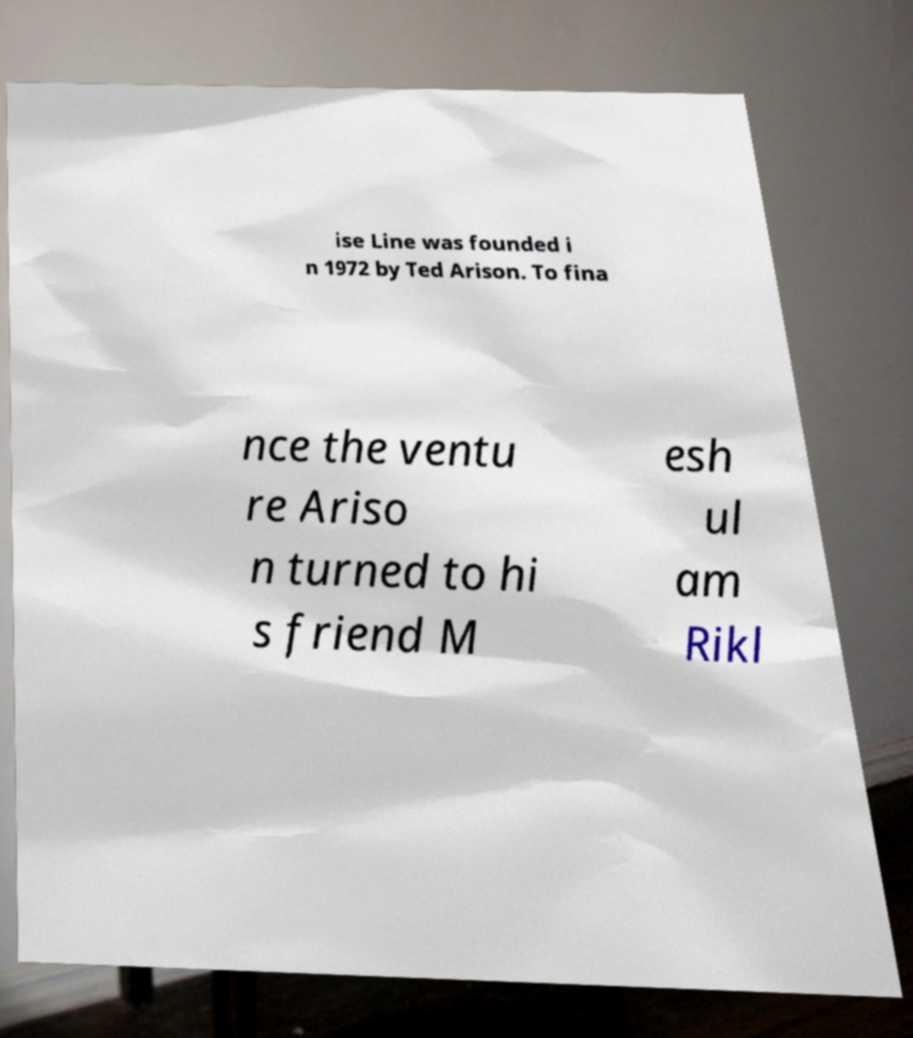There's text embedded in this image that I need extracted. Can you transcribe it verbatim? ise Line was founded i n 1972 by Ted Arison. To fina nce the ventu re Ariso n turned to hi s friend M esh ul am Rikl 